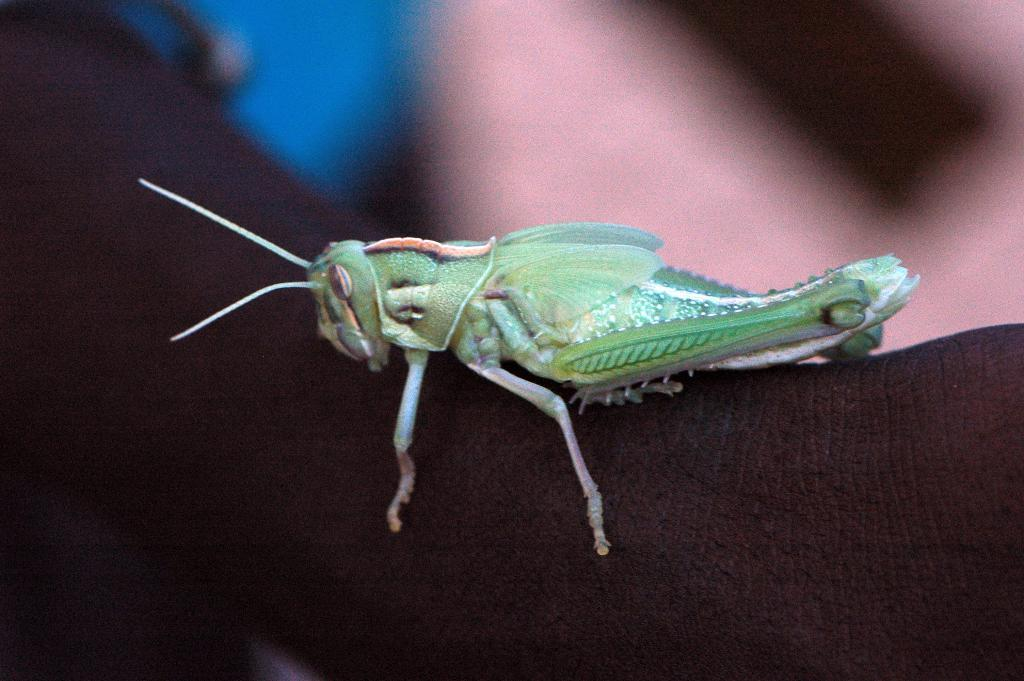What is the main subject of the image? There is a grasshopper in the image. Where is the grasshopper located? The grasshopper is on a person's hand. Can you describe the background of the image? The background of the image is blurred. What book is the person reading in the image? There is no book or reading activity present in the image; it features a grasshopper on a person's hand with a blurred background. 